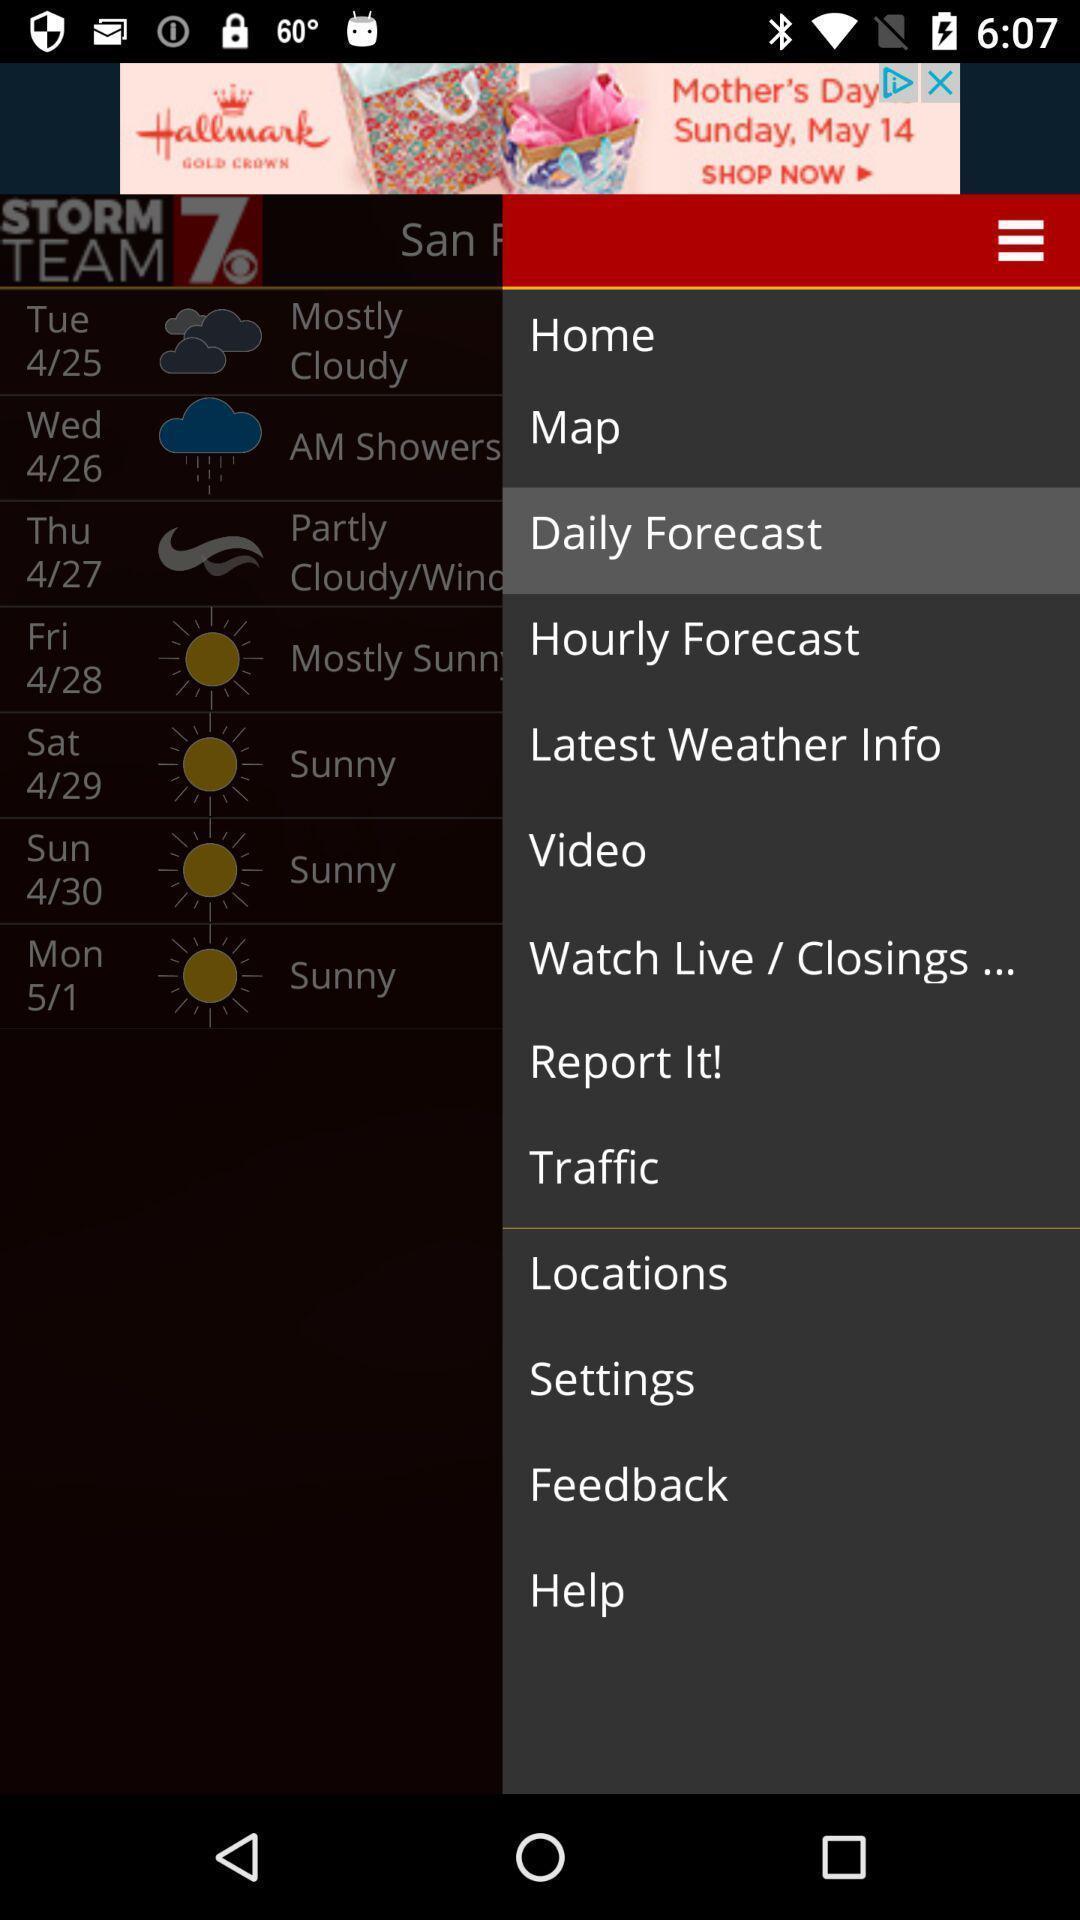Tell me about the visual elements in this screen capture. Pop up displayed with multiple options. 